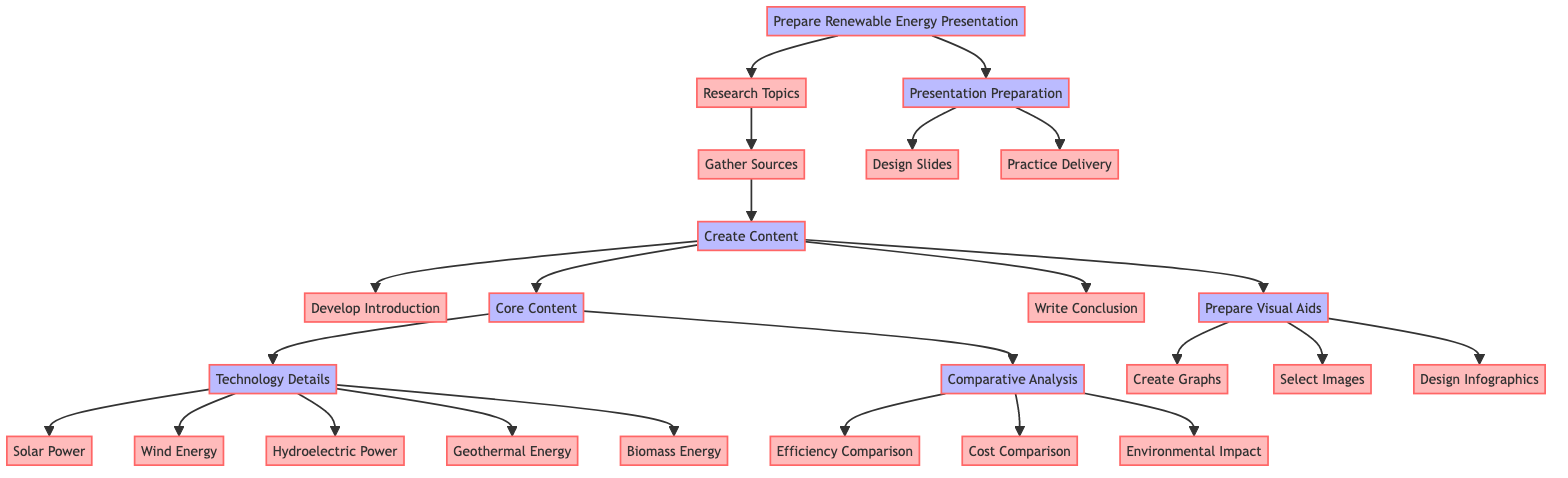What is the first step in preparing the presentation? The first step in the diagram is labeled "Research Topics," which indicates the initial action before moving on to further tasks.
Answer: Research Topics How many renewable energy technologies are detailed in the core content? By counting the nodes connected under "Technology Details," there are five specific technologies listed: Solar Power, Wind Energy, Hydroelectric Power, Geothermal Energy, and Biomass Energy.
Answer: Five What are the sources gathered in the preparation process? The sources gathered are represented as nodes directly connected to "Gather Sources," which lists Scientific Journals, Government Reports, Industry White Papers, and Expert Interviews.
Answer: Scientific Journals, Government Reports, Industry White Papers, Expert Interviews What is the primary focus of the comparative analysis? The primary focus of the comparative analysis, indicated by the node labels, is on "Efficiency," "Cost," and "Environmental Impact," all of which are detailed in the comparison table section.
Answer: Efficiency, Cost, Environmental Impact Which part of the presentation is designed after preparing visual aids? The node "Presentation Preparation" follows directly as the next step after "Prepare Visual Aids," indicating that it is the subsequent focus area once aids are ready.
Answer: Presentation Preparation What type of visual aids are included for the presentation? The diagram indicates that visual aids include "Graphs," "Images," and "Infographics," as seen in the nodes stemming from "Prepare Visual Aids."
Answer: Graphs, Images, Infographics Which technology has the highest efficiency according to the comparative analysis? The node under "Comparison Table" for "Hydroelectric Power" specifies an efficiency of 90%, which is the highest among the listed technologies.
Answer: 90% What action follows the creation of the conclusion? After writing the conclusion, there are no further steps leading from that node, meaning it is the endpoint for that section in the preparation process.
Answer: None What is the last task in the presentation preparation phase? The last task indicated in the "Presentation Preparation" phase is "Practice Delivery," which denotes the final step before the actual presentation takes place.
Answer: Practice Delivery 